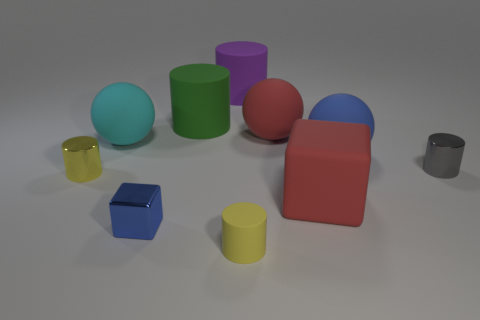Subtract all yellow matte cylinders. How many cylinders are left? 4 Subtract all cyan spheres. How many spheres are left? 2 Subtract all cubes. How many objects are left? 8 Subtract 3 balls. How many balls are left? 0 Add 6 blue things. How many blue things are left? 8 Add 3 green cubes. How many green cubes exist? 3 Subtract 1 yellow cylinders. How many objects are left? 9 Subtract all cyan cylinders. Subtract all cyan cubes. How many cylinders are left? 5 Subtract all red cylinders. How many cyan spheres are left? 1 Subtract all large cyan metallic cylinders. Subtract all cylinders. How many objects are left? 5 